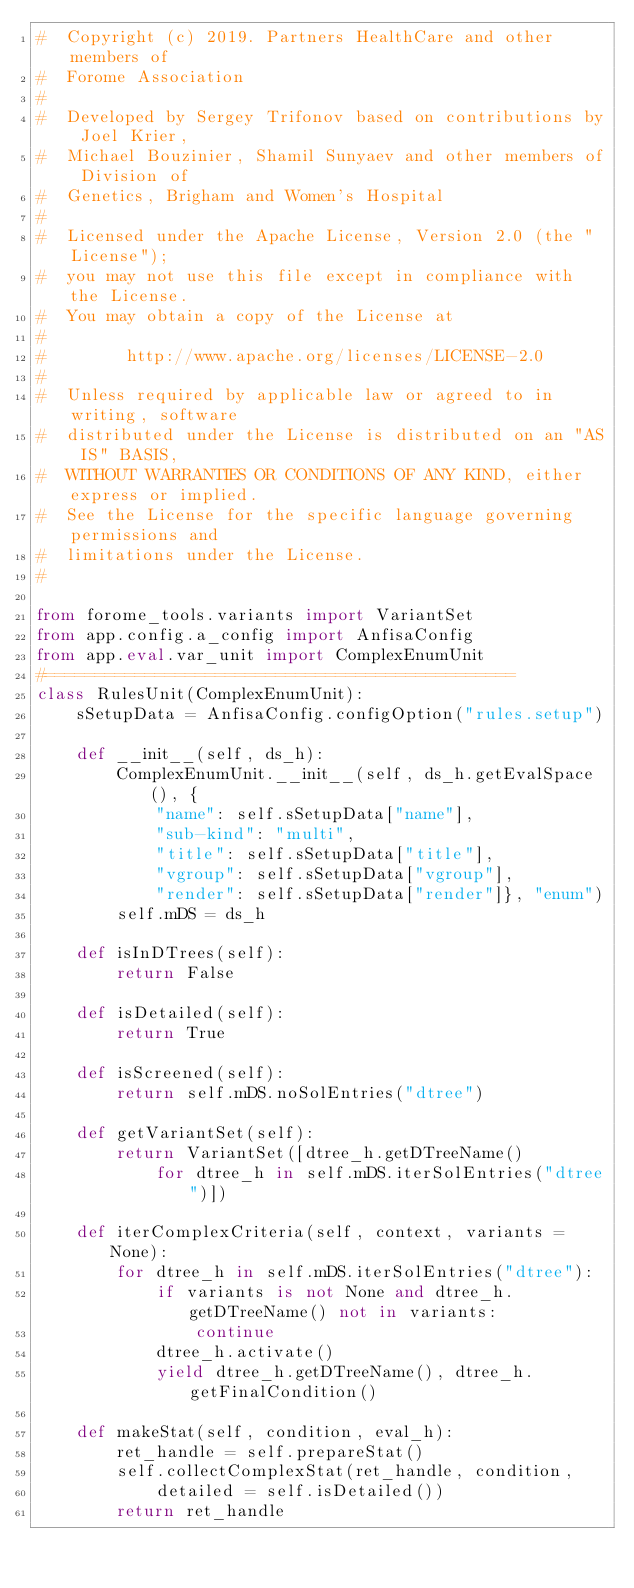<code> <loc_0><loc_0><loc_500><loc_500><_Python_>#  Copyright (c) 2019. Partners HealthCare and other members of
#  Forome Association
#
#  Developed by Sergey Trifonov based on contributions by Joel Krier,
#  Michael Bouzinier, Shamil Sunyaev and other members of Division of
#  Genetics, Brigham and Women's Hospital
#
#  Licensed under the Apache License, Version 2.0 (the "License");
#  you may not use this file except in compliance with the License.
#  You may obtain a copy of the License at
#
#        http://www.apache.org/licenses/LICENSE-2.0
#
#  Unless required by applicable law or agreed to in writing, software
#  distributed under the License is distributed on an "AS IS" BASIS,
#  WITHOUT WARRANTIES OR CONDITIONS OF ANY KIND, either express or implied.
#  See the License for the specific language governing permissions and
#  limitations under the License.
#

from forome_tools.variants import VariantSet
from app.config.a_config import AnfisaConfig
from app.eval.var_unit import ComplexEnumUnit
#===============================================
class RulesUnit(ComplexEnumUnit):
    sSetupData = AnfisaConfig.configOption("rules.setup")

    def __init__(self, ds_h):
        ComplexEnumUnit.__init__(self, ds_h.getEvalSpace(), {
            "name": self.sSetupData["name"],
            "sub-kind": "multi",
            "title": self.sSetupData["title"],
            "vgroup": self.sSetupData["vgroup"],
            "render": self.sSetupData["render"]}, "enum")
        self.mDS = ds_h

    def isInDTrees(self):
        return False

    def isDetailed(self):
        return True

    def isScreened(self):
        return self.mDS.noSolEntries("dtree")

    def getVariantSet(self):
        return VariantSet([dtree_h.getDTreeName()
            for dtree_h in self.mDS.iterSolEntries("dtree")])

    def iterComplexCriteria(self, context, variants = None):
        for dtree_h in self.mDS.iterSolEntries("dtree"):
            if variants is not None and dtree_h.getDTreeName() not in variants:
                continue
            dtree_h.activate()
            yield dtree_h.getDTreeName(), dtree_h.getFinalCondition()

    def makeStat(self, condition, eval_h):
        ret_handle = self.prepareStat()
        self.collectComplexStat(ret_handle, condition,
            detailed = self.isDetailed())
        return ret_handle
</code> 